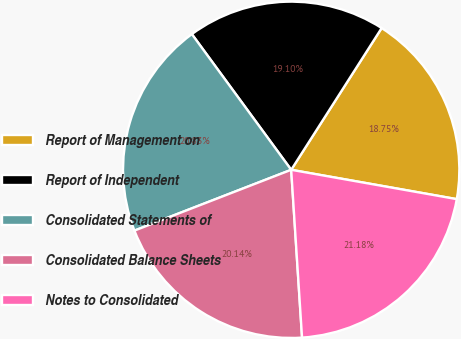Convert chart to OTSL. <chart><loc_0><loc_0><loc_500><loc_500><pie_chart><fcel>Report of Management on<fcel>Report of Independent<fcel>Consolidated Statements of<fcel>Consolidated Balance Sheets<fcel>Notes to Consolidated<nl><fcel>18.75%<fcel>19.1%<fcel>20.83%<fcel>20.14%<fcel>21.18%<nl></chart> 